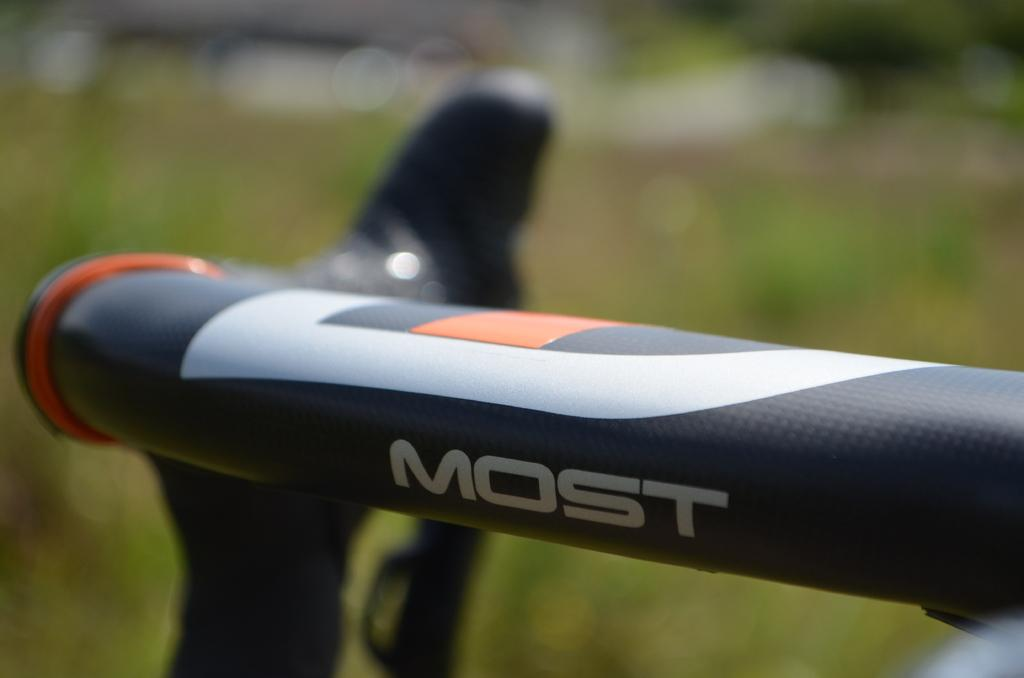What is the main object in the image that has the word "most" written on it? There is an object with "most" written on it in the image. What color is the background of the image? The background of the image is green. Where is the basin located in the image? There is no basin present in the image. What type of vase is depicted in the image? There is no vase present in the image. 